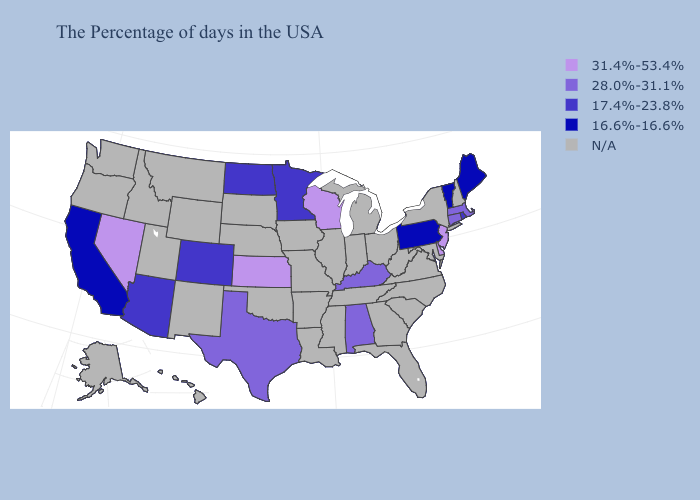How many symbols are there in the legend?
Write a very short answer. 5. What is the value of Wyoming?
Keep it brief. N/A. Name the states that have a value in the range N/A?
Be succinct. New Hampshire, New York, Maryland, Virginia, North Carolina, South Carolina, West Virginia, Ohio, Florida, Georgia, Michigan, Indiana, Tennessee, Illinois, Mississippi, Louisiana, Missouri, Arkansas, Iowa, Nebraska, Oklahoma, South Dakota, Wyoming, New Mexico, Utah, Montana, Idaho, Washington, Oregon, Alaska, Hawaii. What is the lowest value in states that border Virginia?
Short answer required. 28.0%-31.1%. What is the value of Minnesota?
Be succinct. 17.4%-23.8%. Name the states that have a value in the range 31.4%-53.4%?
Keep it brief. New Jersey, Delaware, Wisconsin, Kansas, Nevada. What is the value of Montana?
Short answer required. N/A. What is the value of Nebraska?
Concise answer only. N/A. Name the states that have a value in the range N/A?
Quick response, please. New Hampshire, New York, Maryland, Virginia, North Carolina, South Carolina, West Virginia, Ohio, Florida, Georgia, Michigan, Indiana, Tennessee, Illinois, Mississippi, Louisiana, Missouri, Arkansas, Iowa, Nebraska, Oklahoma, South Dakota, Wyoming, New Mexico, Utah, Montana, Idaho, Washington, Oregon, Alaska, Hawaii. Name the states that have a value in the range 28.0%-31.1%?
Concise answer only. Massachusetts, Connecticut, Kentucky, Alabama, Texas. Among the states that border Colorado , does Arizona have the lowest value?
Answer briefly. Yes. What is the value of Ohio?
Short answer required. N/A. Which states hav the highest value in the West?
Write a very short answer. Nevada. 